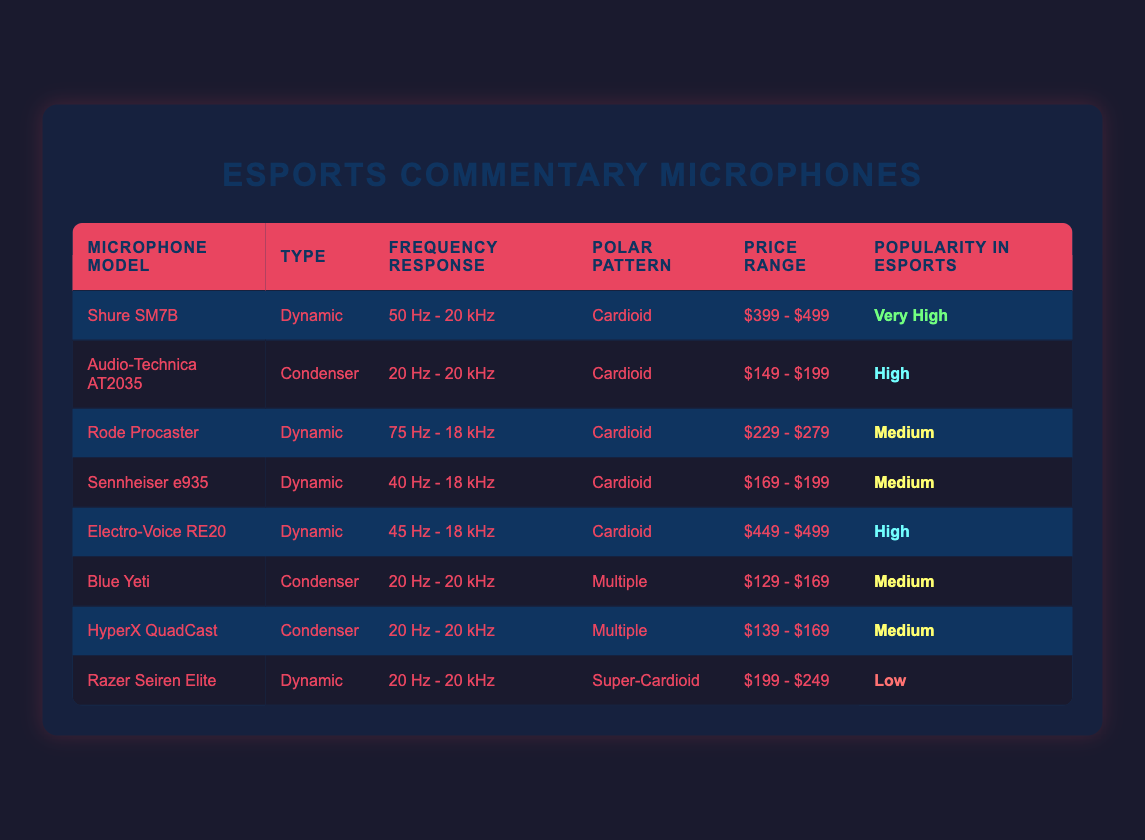What microphone model has the highest price range? Scanning the "Price Range" column, I observe that the Shure SM7B and Electro-Voice RE20 both have a price range of $399 - $499, which is the highest among all models listed.
Answer: Shure SM7B and Electro-Voice RE20 Which type of microphone is most popular in esports? Looking at the "Popularity in Esports" column, I see that the Dynamic type microphones are notably represented among models with "Very High" and "High" popularity. Specifically, both the Shure SM7B and Electro-Voice RE20 are dynamic with high popularity.
Answer: Dynamic What is the frequency response of the Audio-Technica AT2035? By checking the "Frequency Response" column corresponding to the row for the Audio-Technica AT2035, I find that its frequency response is 20 Hz - 20 kHz.
Answer: 20 Hz - 20 kHz How many microphone models are classified as "Medium" popularity? By counting the entries in the "Popularity in Esports" column, I find that there are four microphone models that have a "Medium" popularity: Rode Procaster, Sennheiser e935, Blue Yeti, and HyperX QuadCast.
Answer: Four Are there any microphones with a Super-Cardioid polar pattern? Reviewing the "Polar Pattern" column, I see that the Razer Seiren Elite is the only microphone that has a Super-Cardioid polar pattern.
Answer: Yes Which condenser microphone has the highest frequency response? Looking across the condenser microphones in the table, the Audio-Technica AT2035 has the highest frequency response of 20 Hz - 20 kHz, while the other condenser models also share this range. Since all are equal, it could be said they all have the same highest frequency response.
Answer: Audio-Technica AT2035, Blue Yeti, HyperX QuadCast What is the average price range of all the microphone models? To calculate the average, I first extract the price ranges, converting them into numeric values for calculation. The price ranges converted result in: Shure SM7B ($449), Audio-Technica AT2035 ($174), Rode Procaster ($254), Sennheiser e935 ($184), Electro-Voice RE20 ($474), Blue Yeti ($149), HyperX QuadCast ($154), Razer Seiren Elite ($224). Adding those values gives a total of $18,186 and dividing by 8 results in an average price of about $227.25
Answer: $227.25 Which microphone model offers a polar pattern that is "Multiple"? By examining the "Polar Pattern" column, I see that the Blue Yeti and HyperX QuadCast microphones are both listed under "Multiple."
Answer: Blue Yeti and HyperX QuadCast 